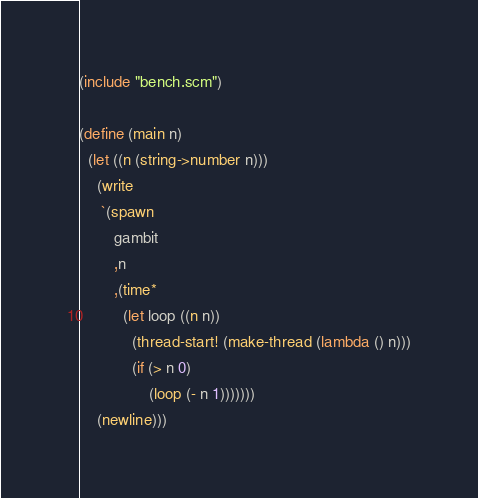Convert code to text. <code><loc_0><loc_0><loc_500><loc_500><_Scheme_>
(include "bench.scm")

(define (main n)
  (let ((n (string->number n)))
    (write
     `(spawn
        gambit
        ,n
        ,(time*
          (let loop ((n n))
            (thread-start! (make-thread (lambda () n)))
            (if (> n 0)
                (loop (- n 1)))))))
    (newline)))
</code> 